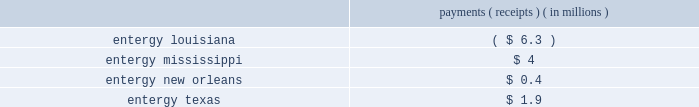Entergy corporation and subsidiaries management 2019s financial discussion and analysis imprudence by the utility operating companies in their execution of their obligations under the system agreement .
See note 2 to the financial statements for discussions of this litigation .
In november 2012 the utility operating companies filed amendments to the system agreement with the ferc pursuant to section 205 of the federal power act .
The amendments consist primarily of the technical revisions needed to the system agreement to ( i ) allocate certain charges and credits from the miso settlement statements to the participating utility operating companies ; and ( ii ) address entergy arkansas 2019s withdrawal from the system agreement .
The lpsc , mpsc , puct , and city council filed protests at the ferc regarding the amendments and other aspects of the utility operating companies 2019 future operating arrangements , including requests that the continued viability of the system agreement in miso ( among other issues ) be set for hearing by the ferc .
In december 2013 the ferc issued an order accepting the revisions filed in november 2012 , subject to a further compliance filing and other conditions .
Entergy services made the requisite compliance filing in february 2014 and the ferc accepted the compliance filing in november 2015 .
In the november 2015 order , the ferc required entergy services to file a refund report consisting of the results of the intra-system bill rerun from december 19 , 2013 through november 30 , 2015 calculating the use of an energy-based allocator to allocate losses , ancillary services charges and credits , and uplift charges and credits to load of each participating utility operating company .
The filing shows the following payments and receipts among the utility operating companies : payments ( receipts ) ( in millions ) .
In the december 2013 order , the ferc set one issue for hearing involving a settlement with union pacific regarding certain coal delivery issues .
Consistent with the decisions described above , entergy arkansas 2019s participation in the system agreement terminated effective december 18 , 2013 .
In december 2014 a ferc alj issued an initial decision finding that entergy arkansas would realize benefits after december 18 , 2013 from the 2008 settlement agreement between entergy services , entergy arkansas , and union pacific , related to certain coal delivery issues .
The alj further found that all of the utility operating companies should share in those benefits pursuant to the methodology proposed by the mpsc .
The utility operating companies and other parties to the proceeding have filed briefs on exceptions and/or briefs opposing exceptions with the ferc challenging various aspects of the december 2014 initial decision and the matter is pending before the ferc .
Utility operating company notices of termination of system agreement participation consistent with their written notices of termination delivered in december 2005 and november 2007 , respectively , entergy arkansas and entergy mississippi filed with the ferc in february 2009 their notices of cancellation to terminate their participation in the system agreement , effective december 18 , 2013 and november 7 , 2015 , respectively .
In november 2009 the ferc accepted the notices of cancellation and determined that entergy arkansas and entergy mississippi are permitted to withdraw from the system agreement following the 96-month notice period without payment of a fee or the requirement to otherwise compensate the remaining utility operating companies as a result of withdrawal .
Appeals by the lpsc and the city council were denied in 2012 and 2013 .
Effective december 18 , 2013 , entergy arkansas ceased participating in the system agreement .
Effective november 7 , 2015 , entergy mississippi ceased participating in the system agreement .
In keeping with their prior commitments and after a careful evaluation of the basis for and continued reasonableness of the 96-month system agreement termination notice period , the utility operating companies filed with the ferc in october 2013 to amend the system agreement changing the notice period for an operating company to .
What are the payments for entergy new orleans as a percentage of payments for entergy texas? 
Computations: (0.4 / 1.9)
Answer: 0.21053. Entergy corporation and subsidiaries management 2019s financial discussion and analysis imprudence by the utility operating companies in their execution of their obligations under the system agreement .
See note 2 to the financial statements for discussions of this litigation .
In november 2012 the utility operating companies filed amendments to the system agreement with the ferc pursuant to section 205 of the federal power act .
The amendments consist primarily of the technical revisions needed to the system agreement to ( i ) allocate certain charges and credits from the miso settlement statements to the participating utility operating companies ; and ( ii ) address entergy arkansas 2019s withdrawal from the system agreement .
The lpsc , mpsc , puct , and city council filed protests at the ferc regarding the amendments and other aspects of the utility operating companies 2019 future operating arrangements , including requests that the continued viability of the system agreement in miso ( among other issues ) be set for hearing by the ferc .
In december 2013 the ferc issued an order accepting the revisions filed in november 2012 , subject to a further compliance filing and other conditions .
Entergy services made the requisite compliance filing in february 2014 and the ferc accepted the compliance filing in november 2015 .
In the november 2015 order , the ferc required entergy services to file a refund report consisting of the results of the intra-system bill rerun from december 19 , 2013 through november 30 , 2015 calculating the use of an energy-based allocator to allocate losses , ancillary services charges and credits , and uplift charges and credits to load of each participating utility operating company .
The filing shows the following payments and receipts among the utility operating companies : payments ( receipts ) ( in millions ) .
In the december 2013 order , the ferc set one issue for hearing involving a settlement with union pacific regarding certain coal delivery issues .
Consistent with the decisions described above , entergy arkansas 2019s participation in the system agreement terminated effective december 18 , 2013 .
In december 2014 a ferc alj issued an initial decision finding that entergy arkansas would realize benefits after december 18 , 2013 from the 2008 settlement agreement between entergy services , entergy arkansas , and union pacific , related to certain coal delivery issues .
The alj further found that all of the utility operating companies should share in those benefits pursuant to the methodology proposed by the mpsc .
The utility operating companies and other parties to the proceeding have filed briefs on exceptions and/or briefs opposing exceptions with the ferc challenging various aspects of the december 2014 initial decision and the matter is pending before the ferc .
Utility operating company notices of termination of system agreement participation consistent with their written notices of termination delivered in december 2005 and november 2007 , respectively , entergy arkansas and entergy mississippi filed with the ferc in february 2009 their notices of cancellation to terminate their participation in the system agreement , effective december 18 , 2013 and november 7 , 2015 , respectively .
In november 2009 the ferc accepted the notices of cancellation and determined that entergy arkansas and entergy mississippi are permitted to withdraw from the system agreement following the 96-month notice period without payment of a fee or the requirement to otherwise compensate the remaining utility operating companies as a result of withdrawal .
Appeals by the lpsc and the city council were denied in 2012 and 2013 .
Effective december 18 , 2013 , entergy arkansas ceased participating in the system agreement .
Effective november 7 , 2015 , entergy mississippi ceased participating in the system agreement .
In keeping with their prior commitments and after a careful evaluation of the basis for and continued reasonableness of the 96-month system agreement termination notice period , the utility operating companies filed with the ferc in october 2013 to amend the system agreement changing the notice period for an operating company to .
What are the payments for entergy texas as a percentage of payments for entergy mississippi? 
Computations: (1.9 / 4)
Answer: 0.475. 